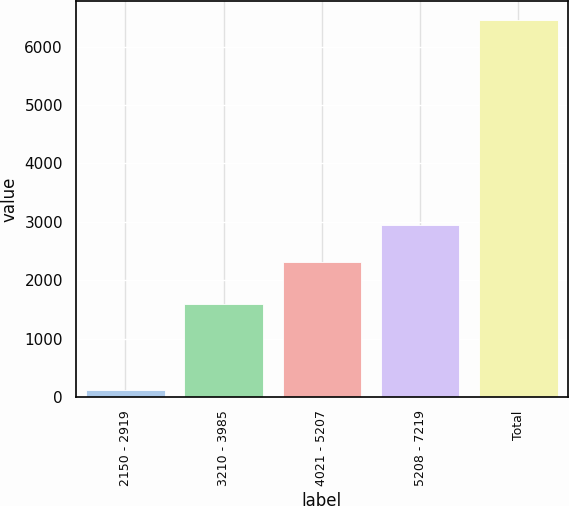<chart> <loc_0><loc_0><loc_500><loc_500><bar_chart><fcel>2150 - 2919<fcel>3210 - 3985<fcel>4021 - 5207<fcel>5208 - 7219<fcel>Total<nl><fcel>115<fcel>1584<fcel>2316<fcel>2950.4<fcel>6459<nl></chart> 